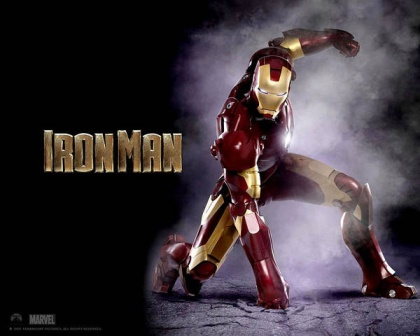Picture Iron Man in the midst of a natural disaster. How might he use his suit to help? During a natural disaster, Iron Man could use his suit's capabilities to provide critical aid. Capable of swiftly navigating through debris-strewn environments, he can deliver supplies, rescue trapped victims, and stabilize collapsing structures. The suit's sensors and communication systems enable him to coordinate with rescue teams, offering aerial reconnaissance and pinpointing areas of highest need. He could employ advanced tools to clear pathways, generate makeshift shelters, and restore communication networks. Iron Man's presence would bring hope and efficient support, exemplifying heroic intervention in times of dire need. 